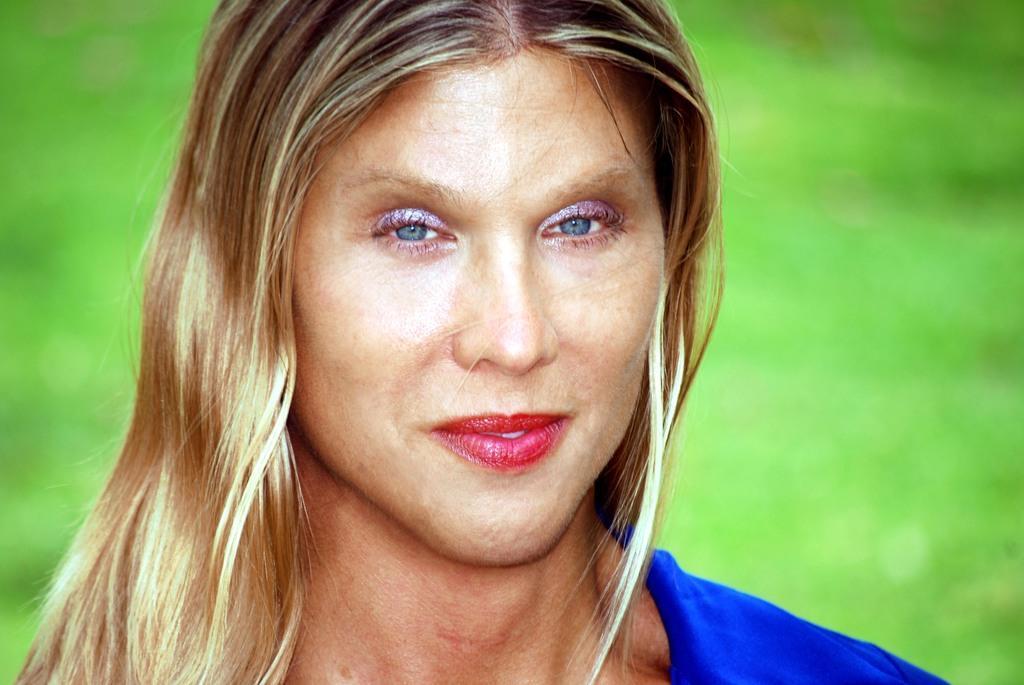Can you describe this image briefly? In this picture I can see a woman in front and I see that she is wearing blue color dress. In the background I see that it is totally green in color. 